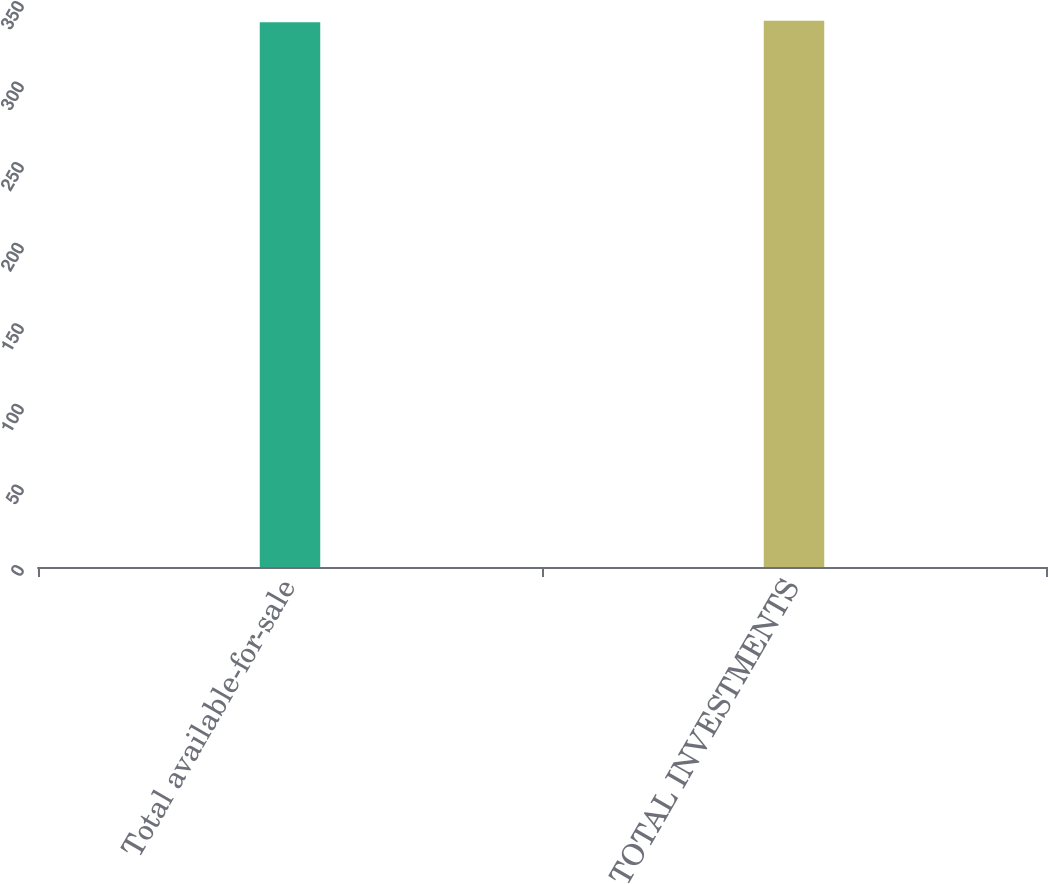Convert chart to OTSL. <chart><loc_0><loc_0><loc_500><loc_500><bar_chart><fcel>Total available-for-sale<fcel>TOTAL INVESTMENTS<nl><fcel>338<fcel>339<nl></chart> 